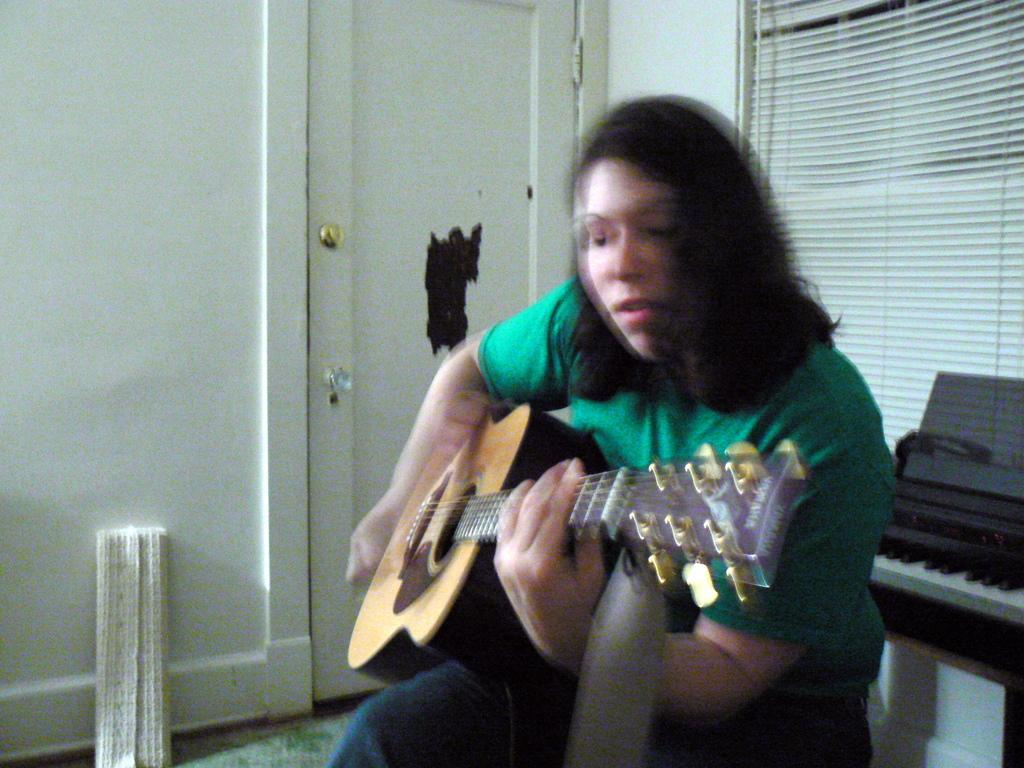Could you give a brief overview of what you see in this image? A woman wearing a green t shirt is holding a guitar and playing. In the back there is a keyboard, curtain. Also there is a cupboard. Near to the cupboard there is a mat. 